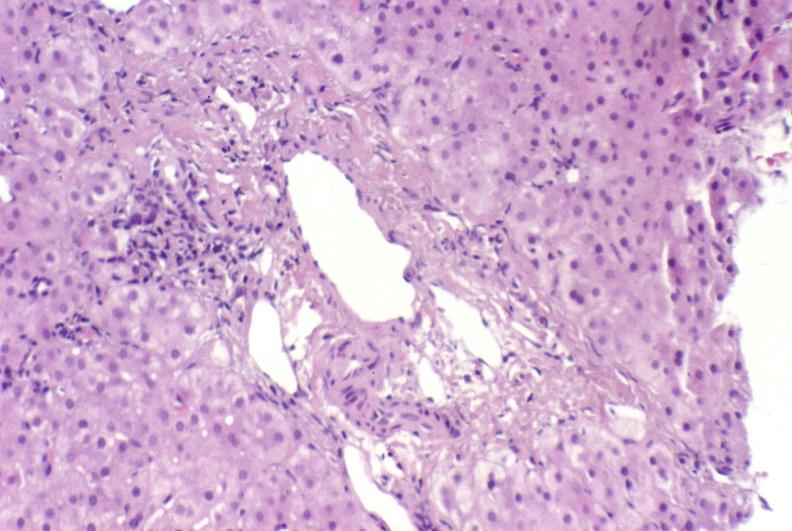what is present?
Answer the question using a single word or phrase. Hepatobiliary 